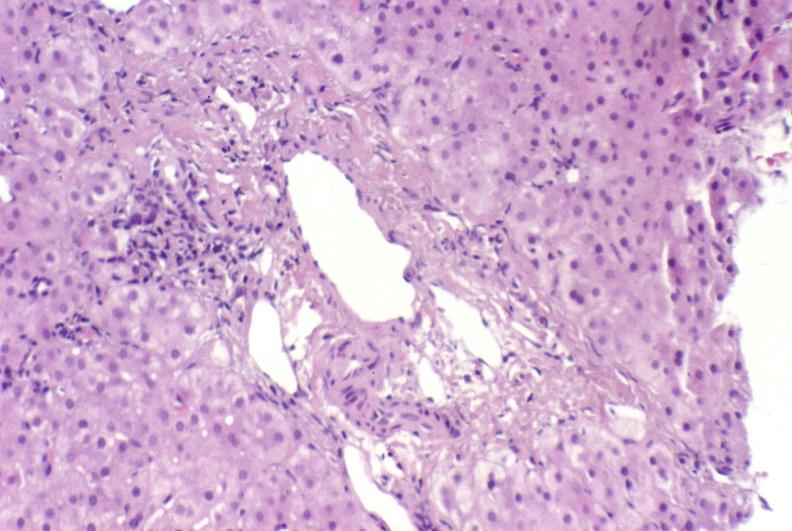what is present?
Answer the question using a single word or phrase. Hepatobiliary 